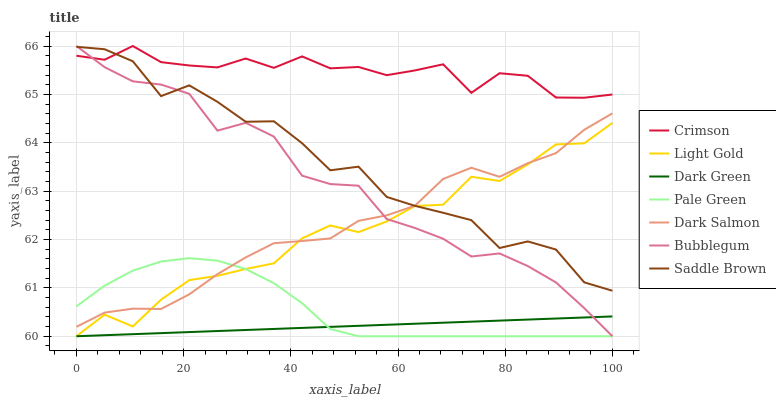Does Dark Green have the minimum area under the curve?
Answer yes or no. Yes. Does Crimson have the maximum area under the curve?
Answer yes or no. Yes. Does Bubblegum have the minimum area under the curve?
Answer yes or no. No. Does Bubblegum have the maximum area under the curve?
Answer yes or no. No. Is Dark Green the smoothest?
Answer yes or no. Yes. Is Saddle Brown the roughest?
Answer yes or no. Yes. Is Bubblegum the smoothest?
Answer yes or no. No. Is Bubblegum the roughest?
Answer yes or no. No. Does Crimson have the lowest value?
Answer yes or no. No. Does Crimson have the highest value?
Answer yes or no. Yes. Does Pale Green have the highest value?
Answer yes or no. No. Is Dark Green less than Dark Salmon?
Answer yes or no. Yes. Is Dark Salmon greater than Dark Green?
Answer yes or no. Yes. Does Dark Green intersect Light Gold?
Answer yes or no. Yes. Is Dark Green less than Light Gold?
Answer yes or no. No. Is Dark Green greater than Light Gold?
Answer yes or no. No. Does Dark Green intersect Dark Salmon?
Answer yes or no. No. 